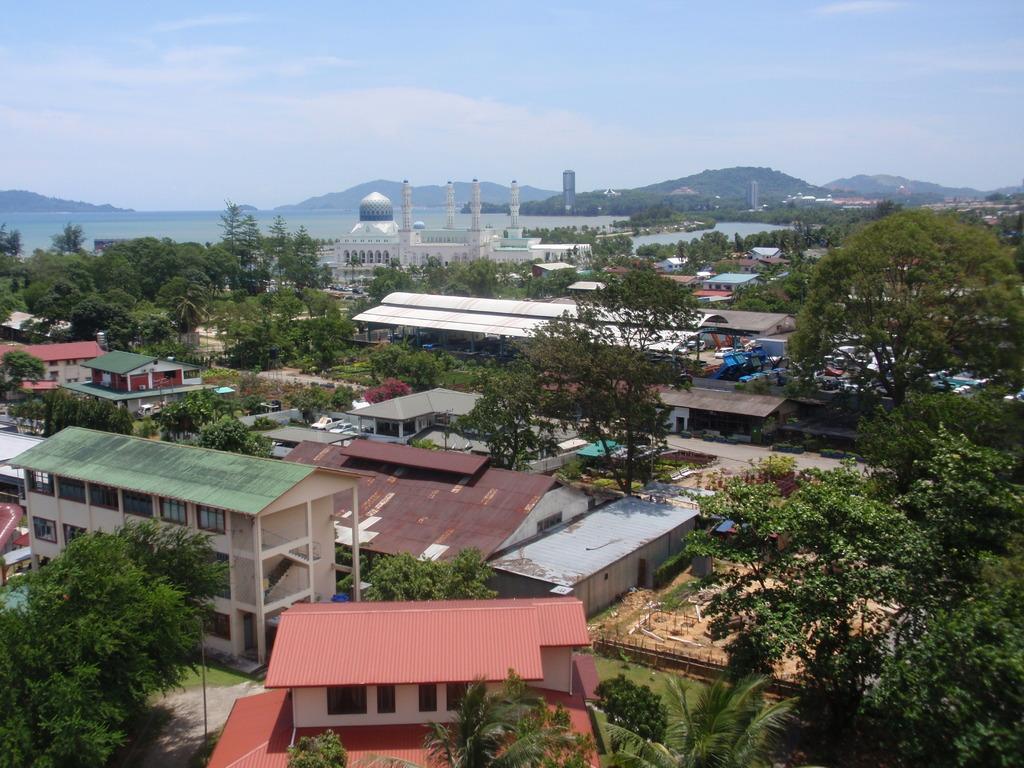How would you summarize this image in a sentence or two? Here there are trees, houses, buildings and a sky is present. 